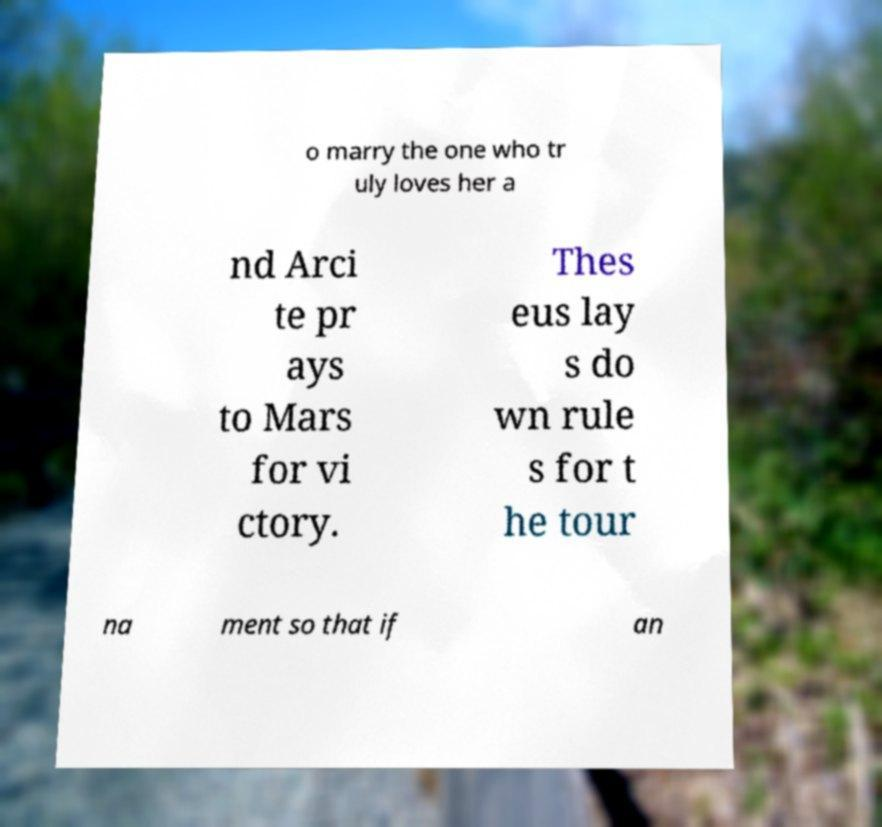There's text embedded in this image that I need extracted. Can you transcribe it verbatim? o marry the one who tr uly loves her a nd Arci te pr ays to Mars for vi ctory. Thes eus lay s do wn rule s for t he tour na ment so that if an 